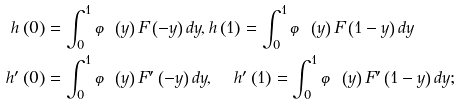Convert formula to latex. <formula><loc_0><loc_0><loc_500><loc_500>h \left ( 0 \right ) & = \int _ { 0 } ^ { 1 } \varphi \left ( y \right ) F \left ( - y \right ) d y , h \left ( 1 \right ) = \int _ { 0 } ^ { 1 } \varphi \left ( y \right ) F \left ( 1 - y \right ) d y \\ h ^ { \prime } \left ( 0 \right ) & = \int _ { 0 } ^ { 1 } \varphi \left ( y \right ) F ^ { \prime } \left ( - y \right ) d y , \quad \, h ^ { \prime } \left ( 1 \right ) = \int _ { 0 } ^ { 1 } \varphi \left ( y \right ) F ^ { \prime } \left ( 1 - y \right ) d y ;</formula> 